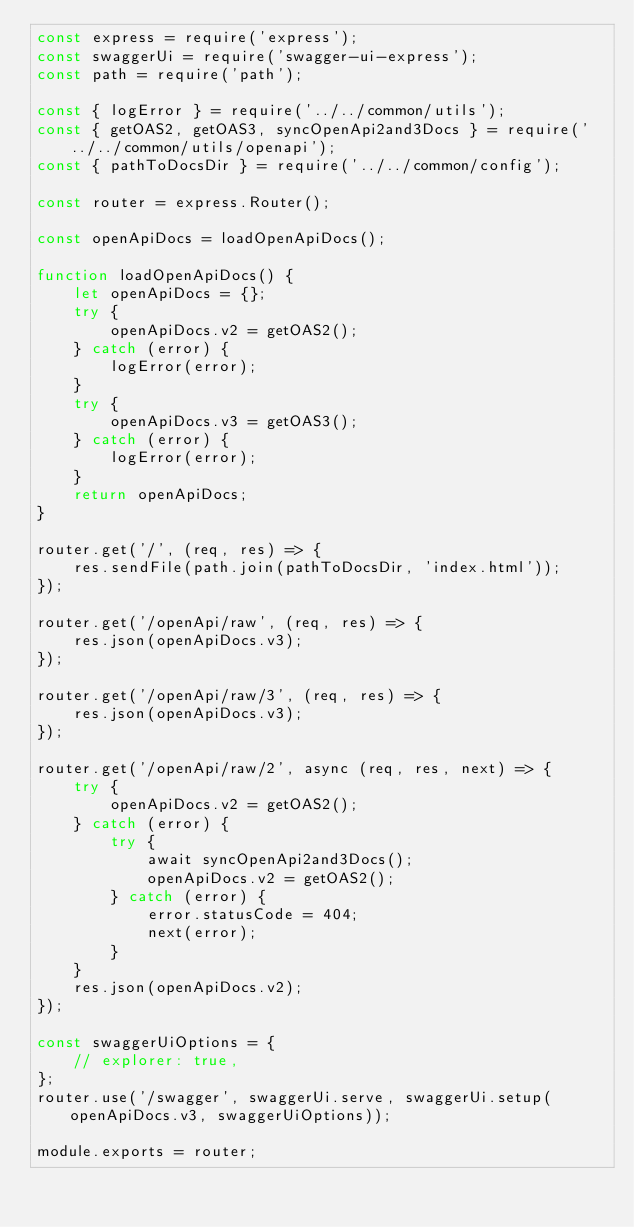Convert code to text. <code><loc_0><loc_0><loc_500><loc_500><_JavaScript_>const express = require('express');
const swaggerUi = require('swagger-ui-express');
const path = require('path');

const { logError } = require('../../common/utils');
const { getOAS2, getOAS3, syncOpenApi2and3Docs } = require('../../common/utils/openapi');
const { pathToDocsDir } = require('../../common/config');

const router = express.Router();

const openApiDocs = loadOpenApiDocs();

function loadOpenApiDocs() {
    let openApiDocs = {};
    try {
        openApiDocs.v2 = getOAS2();
    } catch (error) {
        logError(error);
    }
    try {
        openApiDocs.v3 = getOAS3();
    } catch (error) {
        logError(error);
    }
    return openApiDocs;
}

router.get('/', (req, res) => {
    res.sendFile(path.join(pathToDocsDir, 'index.html'));
});

router.get('/openApi/raw', (req, res) => {
    res.json(openApiDocs.v3);
});

router.get('/openApi/raw/3', (req, res) => {
    res.json(openApiDocs.v3);
});

router.get('/openApi/raw/2', async (req, res, next) => {
    try {
        openApiDocs.v2 = getOAS2();
    } catch (error) {
        try {
            await syncOpenApi2and3Docs();
            openApiDocs.v2 = getOAS2();
        } catch (error) {
            error.statusCode = 404;
            next(error);
        }
    }
    res.json(openApiDocs.v2);
});

const swaggerUiOptions = {
    // explorer: true,
};
router.use('/swagger', swaggerUi.serve, swaggerUi.setup(openApiDocs.v3, swaggerUiOptions));

module.exports = router;
</code> 